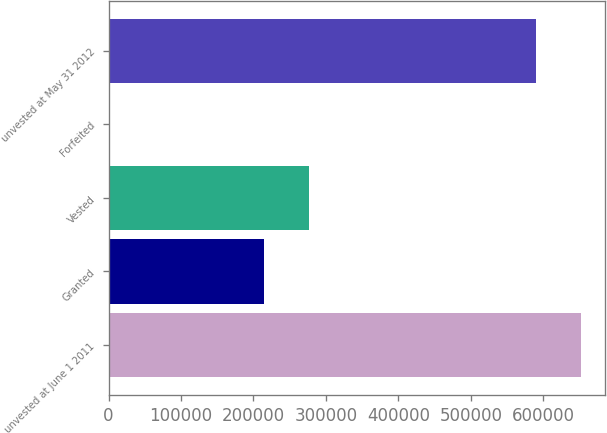<chart> <loc_0><loc_0><loc_500><loc_500><bar_chart><fcel>unvested at June 1 2011<fcel>Granted<fcel>Vested<fcel>Forfeited<fcel>unvested at May 31 2012<nl><fcel>652257<fcel>214435<fcel>276820<fcel>2530<fcel>589872<nl></chart> 